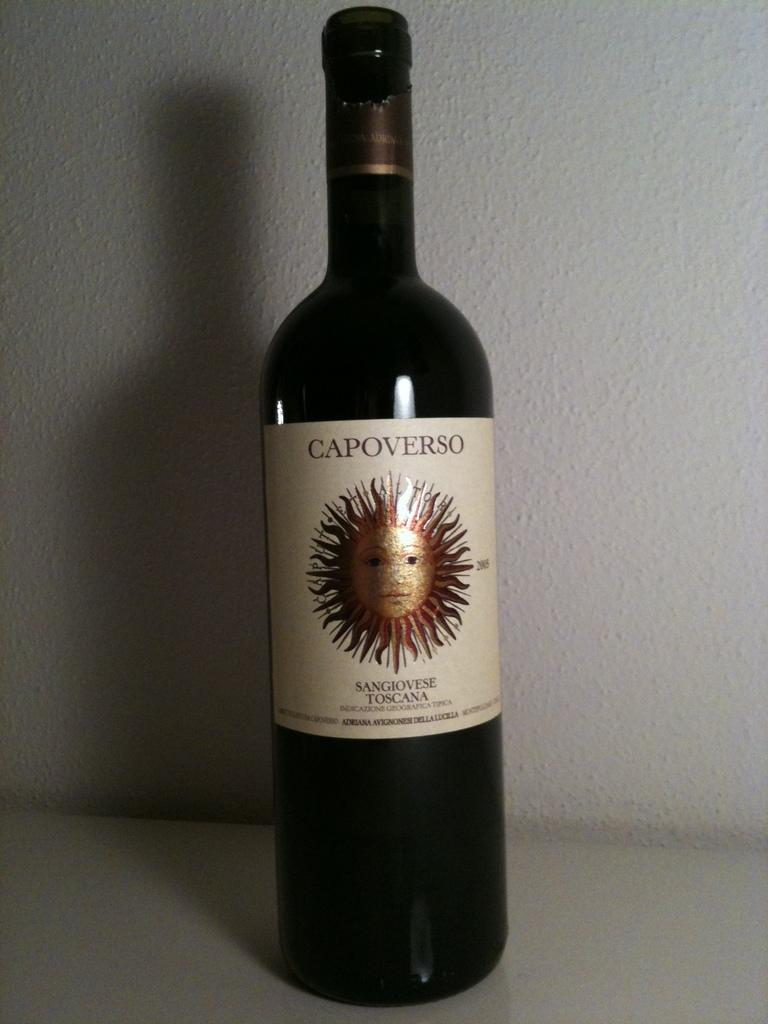<image>
Provide a brief description of the given image. A bottle of wine labelled Capoverso, which has a sun motif. 